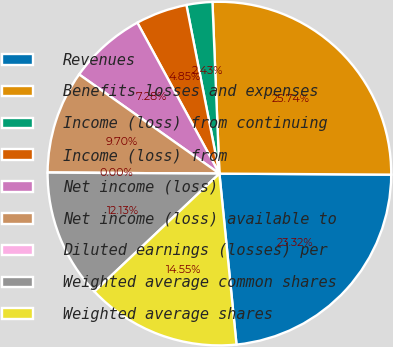<chart> <loc_0><loc_0><loc_500><loc_500><pie_chart><fcel>Revenues<fcel>Benefits losses and expenses<fcel>Income (loss) from continuing<fcel>Income (loss) from<fcel>Net income (loss)<fcel>Net income (loss) available to<fcel>Diluted earnings (losses) per<fcel>Weighted average common shares<fcel>Weighted average shares<nl><fcel>23.32%<fcel>25.74%<fcel>2.43%<fcel>4.85%<fcel>7.28%<fcel>9.7%<fcel>0.0%<fcel>12.13%<fcel>14.55%<nl></chart> 